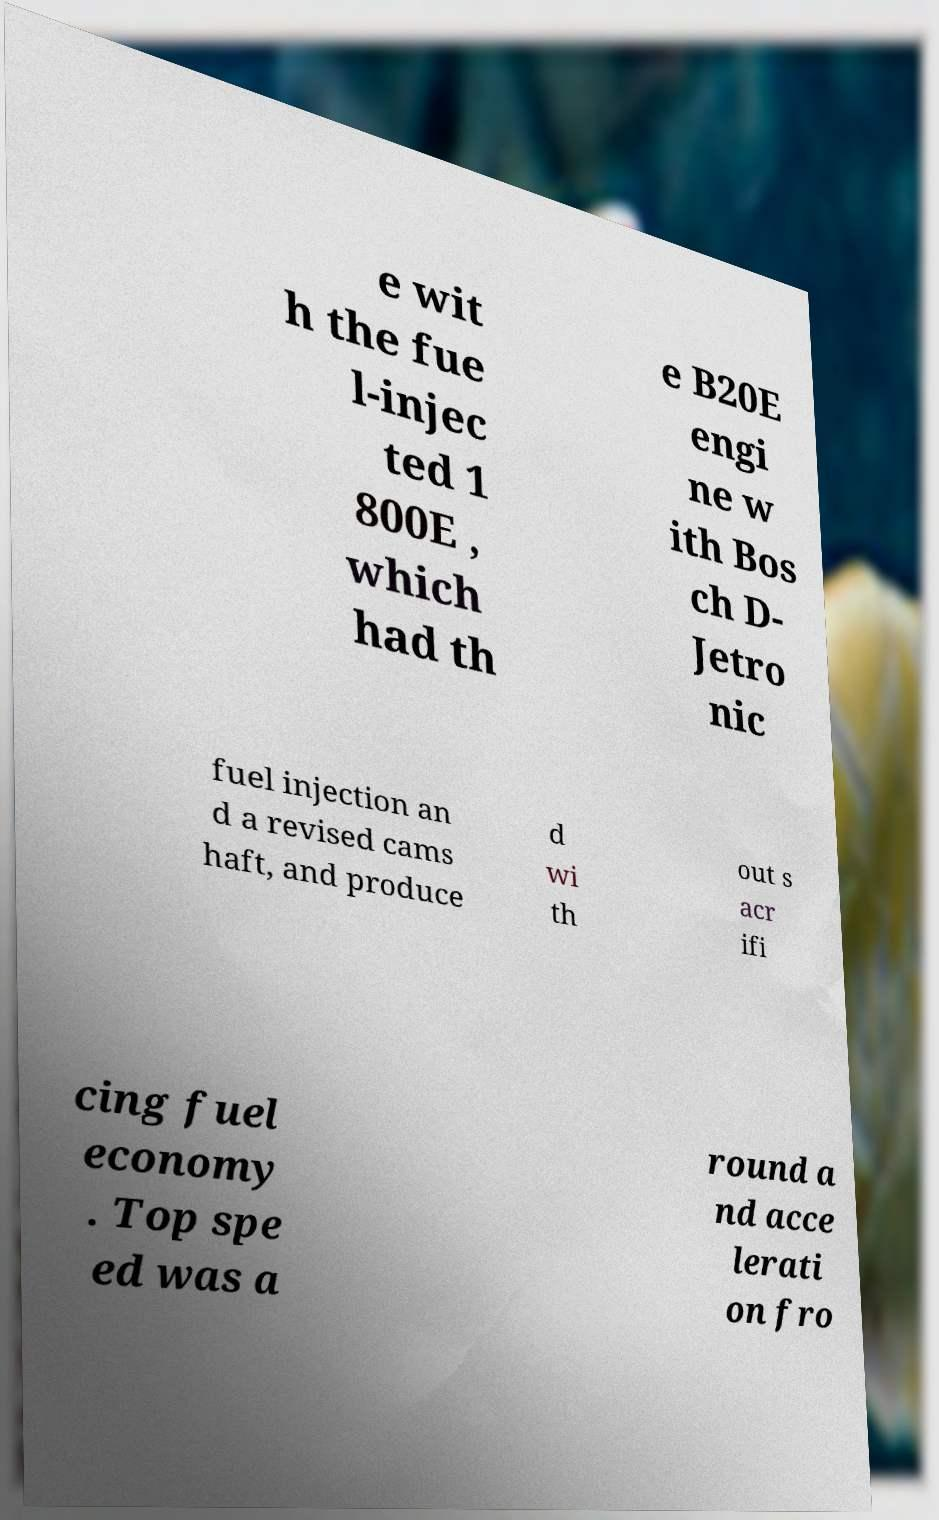Please identify and transcribe the text found in this image. e wit h the fue l-injec ted 1 800E , which had th e B20E engi ne w ith Bos ch D- Jetro nic fuel injection an d a revised cams haft, and produce d wi th out s acr ifi cing fuel economy . Top spe ed was a round a nd acce lerati on fro 